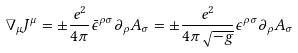Convert formula to latex. <formula><loc_0><loc_0><loc_500><loc_500>\nabla _ { \mu } J ^ { \mu } = \pm \frac { e ^ { 2 } } { 4 \pi } \bar { \epsilon } ^ { \rho \sigma } \partial _ { \rho } A _ { \sigma } = \pm \frac { e ^ { 2 } } { 4 \pi \sqrt { - g } } \epsilon ^ { \rho \sigma } \partial _ { \rho } A _ { \sigma }</formula> 